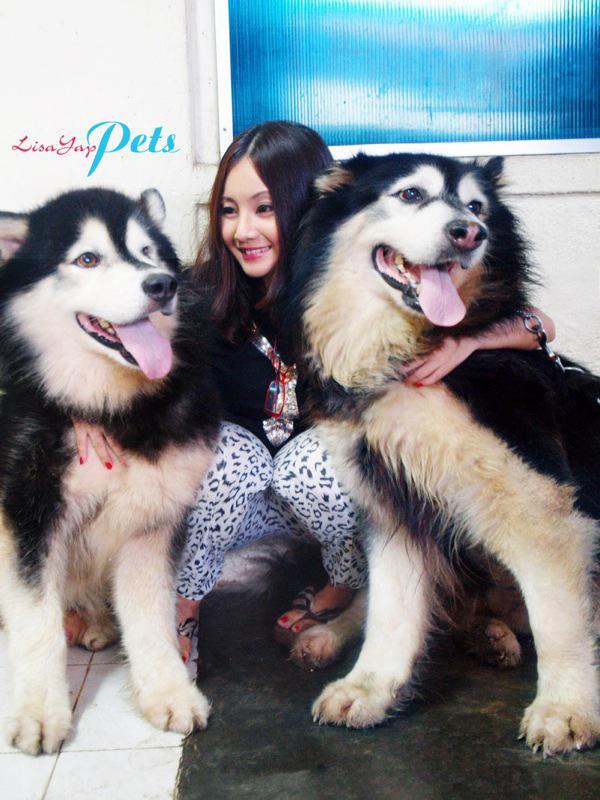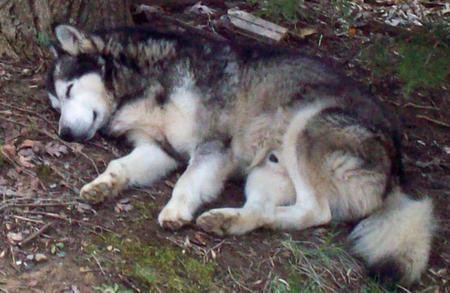The first image is the image on the left, the second image is the image on the right. Given the left and right images, does the statement "The left image contains no more than one dog." hold true? Answer yes or no. No. The first image is the image on the left, the second image is the image on the right. Assess this claim about the two images: "A dark-haired girl has her arms around at least one dog in one image, and the other image shows just one dog that is not interacting.". Correct or not? Answer yes or no. Yes. 